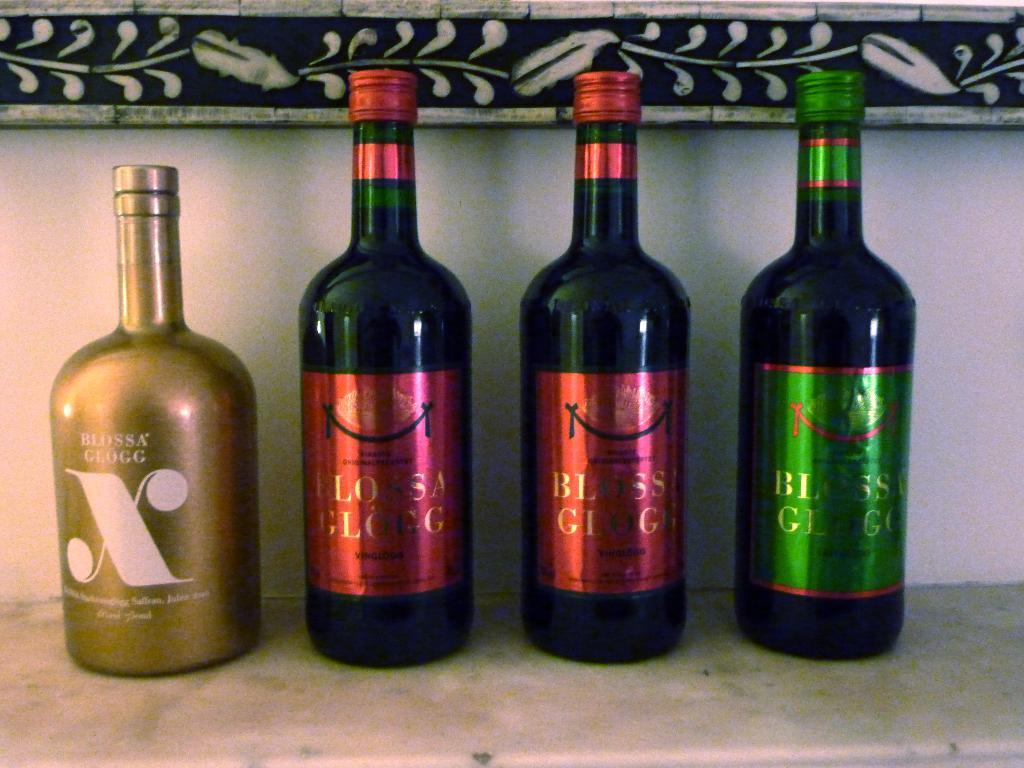<image>
Write a terse but informative summary of the picture. 4 bottles next to each other from Blossa Glugg. 